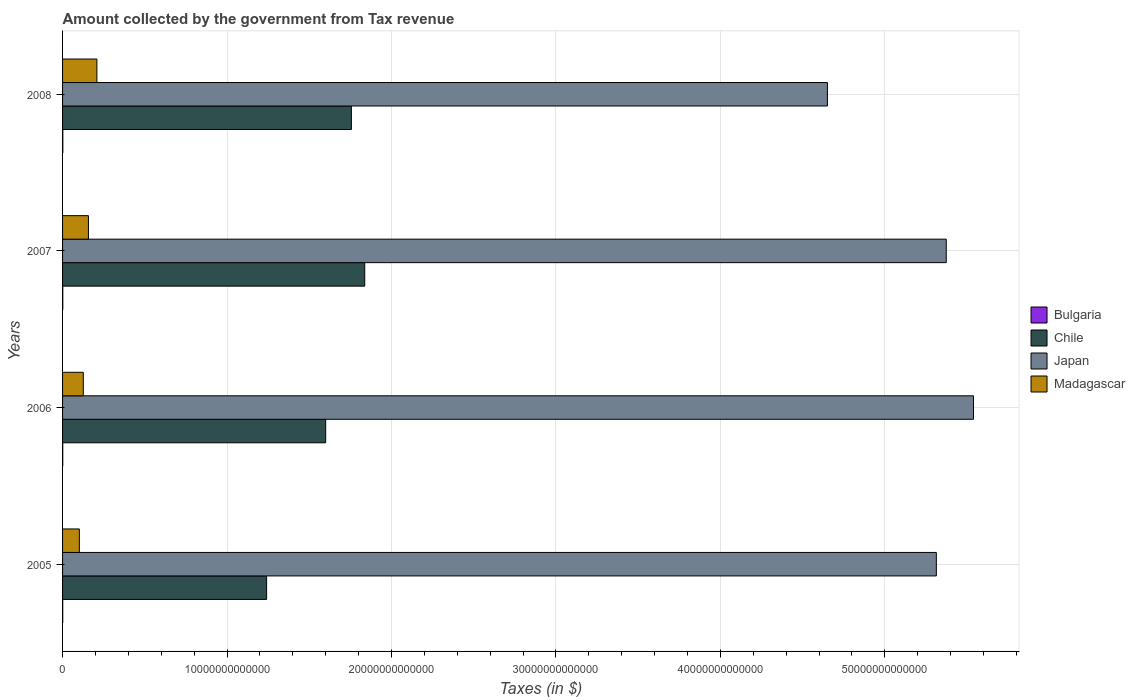How many different coloured bars are there?
Your answer should be very brief. 4. How many groups of bars are there?
Give a very brief answer. 4. How many bars are there on the 2nd tick from the top?
Your answer should be compact. 4. How many bars are there on the 3rd tick from the bottom?
Offer a terse response. 4. What is the amount collected by the government from tax revenue in Japan in 2006?
Keep it short and to the point. 5.54e+13. Across all years, what is the maximum amount collected by the government from tax revenue in Bulgaria?
Provide a short and direct response. 1.61e+1. Across all years, what is the minimum amount collected by the government from tax revenue in Bulgaria?
Ensure brevity in your answer.  9.83e+09. In which year was the amount collected by the government from tax revenue in Japan maximum?
Ensure brevity in your answer.  2006. In which year was the amount collected by the government from tax revenue in Japan minimum?
Your answer should be compact. 2008. What is the total amount collected by the government from tax revenue in Madagascar in the graph?
Keep it short and to the point. 5.94e+12. What is the difference between the amount collected by the government from tax revenue in Bulgaria in 2006 and that in 2007?
Offer a terse response. -2.27e+09. What is the difference between the amount collected by the government from tax revenue in Chile in 2006 and the amount collected by the government from tax revenue in Bulgaria in 2007?
Make the answer very short. 1.60e+13. What is the average amount collected by the government from tax revenue in Madagascar per year?
Provide a short and direct response. 1.49e+12. In the year 2006, what is the difference between the amount collected by the government from tax revenue in Bulgaria and amount collected by the government from tax revenue in Chile?
Offer a terse response. -1.60e+13. What is the ratio of the amount collected by the government from tax revenue in Bulgaria in 2007 to that in 2008?
Keep it short and to the point. 0.86. Is the amount collected by the government from tax revenue in Japan in 2006 less than that in 2007?
Make the answer very short. No. Is the difference between the amount collected by the government from tax revenue in Bulgaria in 2006 and 2008 greater than the difference between the amount collected by the government from tax revenue in Chile in 2006 and 2008?
Provide a succinct answer. Yes. What is the difference between the highest and the second highest amount collected by the government from tax revenue in Japan?
Offer a terse response. 1.66e+12. What is the difference between the highest and the lowest amount collected by the government from tax revenue in Japan?
Give a very brief answer. 8.88e+12. Is the sum of the amount collected by the government from tax revenue in Madagascar in 2005 and 2008 greater than the maximum amount collected by the government from tax revenue in Japan across all years?
Your answer should be compact. No. What does the 3rd bar from the top in 2005 represents?
Provide a short and direct response. Chile. What does the 4th bar from the bottom in 2006 represents?
Give a very brief answer. Madagascar. How many bars are there?
Provide a short and direct response. 16. Are all the bars in the graph horizontal?
Offer a very short reply. Yes. What is the difference between two consecutive major ticks on the X-axis?
Your answer should be compact. 1.00e+13. Are the values on the major ticks of X-axis written in scientific E-notation?
Offer a terse response. No. Does the graph contain any zero values?
Your response must be concise. No. Does the graph contain grids?
Offer a very short reply. Yes. How many legend labels are there?
Offer a very short reply. 4. What is the title of the graph?
Provide a succinct answer. Amount collected by the government from Tax revenue. Does "Mauritania" appear as one of the legend labels in the graph?
Offer a terse response. No. What is the label or title of the X-axis?
Make the answer very short. Taxes (in $). What is the label or title of the Y-axis?
Ensure brevity in your answer.  Years. What is the Taxes (in $) in Bulgaria in 2005?
Provide a short and direct response. 9.83e+09. What is the Taxes (in $) in Chile in 2005?
Offer a terse response. 1.24e+13. What is the Taxes (in $) in Japan in 2005?
Your answer should be very brief. 5.31e+13. What is the Taxes (in $) of Madagascar in 2005?
Your response must be concise. 1.02e+12. What is the Taxes (in $) in Bulgaria in 2006?
Your answer should be very brief. 1.17e+1. What is the Taxes (in $) in Chile in 2006?
Your answer should be compact. 1.60e+13. What is the Taxes (in $) of Japan in 2006?
Keep it short and to the point. 5.54e+13. What is the Taxes (in $) of Madagascar in 2006?
Your answer should be compact. 1.26e+12. What is the Taxes (in $) in Bulgaria in 2007?
Your answer should be very brief. 1.39e+1. What is the Taxes (in $) in Chile in 2007?
Your answer should be compact. 1.84e+13. What is the Taxes (in $) of Japan in 2007?
Your answer should be compact. 5.37e+13. What is the Taxes (in $) of Madagascar in 2007?
Your response must be concise. 1.57e+12. What is the Taxes (in $) in Bulgaria in 2008?
Provide a short and direct response. 1.61e+1. What is the Taxes (in $) in Chile in 2008?
Provide a succinct answer. 1.76e+13. What is the Taxes (in $) of Japan in 2008?
Provide a short and direct response. 4.65e+13. What is the Taxes (in $) of Madagascar in 2008?
Provide a succinct answer. 2.09e+12. Across all years, what is the maximum Taxes (in $) of Bulgaria?
Provide a succinct answer. 1.61e+1. Across all years, what is the maximum Taxes (in $) in Chile?
Provide a short and direct response. 1.84e+13. Across all years, what is the maximum Taxes (in $) in Japan?
Your answer should be compact. 5.54e+13. Across all years, what is the maximum Taxes (in $) of Madagascar?
Offer a very short reply. 2.09e+12. Across all years, what is the minimum Taxes (in $) of Bulgaria?
Make the answer very short. 9.83e+09. Across all years, what is the minimum Taxes (in $) in Chile?
Make the answer very short. 1.24e+13. Across all years, what is the minimum Taxes (in $) in Japan?
Provide a succinct answer. 4.65e+13. Across all years, what is the minimum Taxes (in $) of Madagascar?
Ensure brevity in your answer.  1.02e+12. What is the total Taxes (in $) of Bulgaria in the graph?
Provide a short and direct response. 5.15e+1. What is the total Taxes (in $) of Chile in the graph?
Give a very brief answer. 6.43e+13. What is the total Taxes (in $) of Japan in the graph?
Keep it short and to the point. 2.09e+14. What is the total Taxes (in $) in Madagascar in the graph?
Provide a short and direct response. 5.94e+12. What is the difference between the Taxes (in $) of Bulgaria in 2005 and that in 2006?
Your answer should be compact. -1.82e+09. What is the difference between the Taxes (in $) of Chile in 2005 and that in 2006?
Your answer should be compact. -3.59e+12. What is the difference between the Taxes (in $) in Japan in 2005 and that in 2006?
Ensure brevity in your answer.  -2.26e+12. What is the difference between the Taxes (in $) of Madagascar in 2005 and that in 2006?
Provide a short and direct response. -2.41e+11. What is the difference between the Taxes (in $) in Bulgaria in 2005 and that in 2007?
Your answer should be very brief. -4.09e+09. What is the difference between the Taxes (in $) in Chile in 2005 and that in 2007?
Ensure brevity in your answer.  -5.97e+12. What is the difference between the Taxes (in $) in Japan in 2005 and that in 2007?
Provide a succinct answer. -6.02e+11. What is the difference between the Taxes (in $) in Madagascar in 2005 and that in 2007?
Your response must be concise. -5.53e+11. What is the difference between the Taxes (in $) in Bulgaria in 2005 and that in 2008?
Your answer should be very brief. -6.30e+09. What is the difference between the Taxes (in $) of Chile in 2005 and that in 2008?
Keep it short and to the point. -5.15e+12. What is the difference between the Taxes (in $) in Japan in 2005 and that in 2008?
Provide a short and direct response. 6.62e+12. What is the difference between the Taxes (in $) of Madagascar in 2005 and that in 2008?
Ensure brevity in your answer.  -1.07e+12. What is the difference between the Taxes (in $) in Bulgaria in 2006 and that in 2007?
Keep it short and to the point. -2.27e+09. What is the difference between the Taxes (in $) of Chile in 2006 and that in 2007?
Ensure brevity in your answer.  -2.37e+12. What is the difference between the Taxes (in $) in Japan in 2006 and that in 2007?
Your answer should be very brief. 1.66e+12. What is the difference between the Taxes (in $) of Madagascar in 2006 and that in 2007?
Keep it short and to the point. -3.12e+11. What is the difference between the Taxes (in $) of Bulgaria in 2006 and that in 2008?
Your answer should be compact. -4.47e+09. What is the difference between the Taxes (in $) of Chile in 2006 and that in 2008?
Provide a succinct answer. -1.56e+12. What is the difference between the Taxes (in $) in Japan in 2006 and that in 2008?
Your response must be concise. 8.88e+12. What is the difference between the Taxes (in $) of Madagascar in 2006 and that in 2008?
Keep it short and to the point. -8.26e+11. What is the difference between the Taxes (in $) of Bulgaria in 2007 and that in 2008?
Your response must be concise. -2.20e+09. What is the difference between the Taxes (in $) of Chile in 2007 and that in 2008?
Provide a short and direct response. 8.12e+11. What is the difference between the Taxes (in $) in Japan in 2007 and that in 2008?
Your response must be concise. 7.23e+12. What is the difference between the Taxes (in $) of Madagascar in 2007 and that in 2008?
Your answer should be compact. -5.14e+11. What is the difference between the Taxes (in $) of Bulgaria in 2005 and the Taxes (in $) of Chile in 2006?
Your answer should be compact. -1.60e+13. What is the difference between the Taxes (in $) of Bulgaria in 2005 and the Taxes (in $) of Japan in 2006?
Offer a terse response. -5.54e+13. What is the difference between the Taxes (in $) in Bulgaria in 2005 and the Taxes (in $) in Madagascar in 2006?
Offer a terse response. -1.25e+12. What is the difference between the Taxes (in $) in Chile in 2005 and the Taxes (in $) in Japan in 2006?
Offer a terse response. -4.30e+13. What is the difference between the Taxes (in $) in Chile in 2005 and the Taxes (in $) in Madagascar in 2006?
Offer a very short reply. 1.11e+13. What is the difference between the Taxes (in $) of Japan in 2005 and the Taxes (in $) of Madagascar in 2006?
Your response must be concise. 5.19e+13. What is the difference between the Taxes (in $) of Bulgaria in 2005 and the Taxes (in $) of Chile in 2007?
Your answer should be very brief. -1.84e+13. What is the difference between the Taxes (in $) of Bulgaria in 2005 and the Taxes (in $) of Japan in 2007?
Make the answer very short. -5.37e+13. What is the difference between the Taxes (in $) in Bulgaria in 2005 and the Taxes (in $) in Madagascar in 2007?
Keep it short and to the point. -1.56e+12. What is the difference between the Taxes (in $) in Chile in 2005 and the Taxes (in $) in Japan in 2007?
Provide a short and direct response. -4.13e+13. What is the difference between the Taxes (in $) in Chile in 2005 and the Taxes (in $) in Madagascar in 2007?
Provide a short and direct response. 1.08e+13. What is the difference between the Taxes (in $) of Japan in 2005 and the Taxes (in $) of Madagascar in 2007?
Give a very brief answer. 5.16e+13. What is the difference between the Taxes (in $) of Bulgaria in 2005 and the Taxes (in $) of Chile in 2008?
Give a very brief answer. -1.76e+13. What is the difference between the Taxes (in $) in Bulgaria in 2005 and the Taxes (in $) in Japan in 2008?
Your answer should be compact. -4.65e+13. What is the difference between the Taxes (in $) in Bulgaria in 2005 and the Taxes (in $) in Madagascar in 2008?
Provide a succinct answer. -2.08e+12. What is the difference between the Taxes (in $) in Chile in 2005 and the Taxes (in $) in Japan in 2008?
Make the answer very short. -3.41e+13. What is the difference between the Taxes (in $) in Chile in 2005 and the Taxes (in $) in Madagascar in 2008?
Keep it short and to the point. 1.03e+13. What is the difference between the Taxes (in $) of Japan in 2005 and the Taxes (in $) of Madagascar in 2008?
Your answer should be very brief. 5.10e+13. What is the difference between the Taxes (in $) in Bulgaria in 2006 and the Taxes (in $) in Chile in 2007?
Your answer should be very brief. -1.84e+13. What is the difference between the Taxes (in $) in Bulgaria in 2006 and the Taxes (in $) in Japan in 2007?
Provide a short and direct response. -5.37e+13. What is the difference between the Taxes (in $) of Bulgaria in 2006 and the Taxes (in $) of Madagascar in 2007?
Provide a short and direct response. -1.56e+12. What is the difference between the Taxes (in $) of Chile in 2006 and the Taxes (in $) of Japan in 2007?
Provide a succinct answer. -3.77e+13. What is the difference between the Taxes (in $) in Chile in 2006 and the Taxes (in $) in Madagascar in 2007?
Keep it short and to the point. 1.44e+13. What is the difference between the Taxes (in $) in Japan in 2006 and the Taxes (in $) in Madagascar in 2007?
Make the answer very short. 5.38e+13. What is the difference between the Taxes (in $) in Bulgaria in 2006 and the Taxes (in $) in Chile in 2008?
Offer a terse response. -1.76e+13. What is the difference between the Taxes (in $) of Bulgaria in 2006 and the Taxes (in $) of Japan in 2008?
Offer a terse response. -4.65e+13. What is the difference between the Taxes (in $) in Bulgaria in 2006 and the Taxes (in $) in Madagascar in 2008?
Give a very brief answer. -2.08e+12. What is the difference between the Taxes (in $) in Chile in 2006 and the Taxes (in $) in Japan in 2008?
Your response must be concise. -3.05e+13. What is the difference between the Taxes (in $) of Chile in 2006 and the Taxes (in $) of Madagascar in 2008?
Keep it short and to the point. 1.39e+13. What is the difference between the Taxes (in $) in Japan in 2006 and the Taxes (in $) in Madagascar in 2008?
Your answer should be very brief. 5.33e+13. What is the difference between the Taxes (in $) of Bulgaria in 2007 and the Taxes (in $) of Chile in 2008?
Provide a succinct answer. -1.75e+13. What is the difference between the Taxes (in $) in Bulgaria in 2007 and the Taxes (in $) in Japan in 2008?
Offer a very short reply. -4.65e+13. What is the difference between the Taxes (in $) of Bulgaria in 2007 and the Taxes (in $) of Madagascar in 2008?
Your response must be concise. -2.07e+12. What is the difference between the Taxes (in $) of Chile in 2007 and the Taxes (in $) of Japan in 2008?
Your answer should be compact. -2.81e+13. What is the difference between the Taxes (in $) in Chile in 2007 and the Taxes (in $) in Madagascar in 2008?
Your answer should be compact. 1.63e+13. What is the difference between the Taxes (in $) in Japan in 2007 and the Taxes (in $) in Madagascar in 2008?
Give a very brief answer. 5.16e+13. What is the average Taxes (in $) in Bulgaria per year?
Your answer should be compact. 1.29e+1. What is the average Taxes (in $) in Chile per year?
Make the answer very short. 1.61e+13. What is the average Taxes (in $) in Japan per year?
Make the answer very short. 5.22e+13. What is the average Taxes (in $) of Madagascar per year?
Your answer should be compact. 1.49e+12. In the year 2005, what is the difference between the Taxes (in $) of Bulgaria and Taxes (in $) of Chile?
Your response must be concise. -1.24e+13. In the year 2005, what is the difference between the Taxes (in $) of Bulgaria and Taxes (in $) of Japan?
Keep it short and to the point. -5.31e+13. In the year 2005, what is the difference between the Taxes (in $) in Bulgaria and Taxes (in $) in Madagascar?
Give a very brief answer. -1.01e+12. In the year 2005, what is the difference between the Taxes (in $) in Chile and Taxes (in $) in Japan?
Your answer should be very brief. -4.07e+13. In the year 2005, what is the difference between the Taxes (in $) in Chile and Taxes (in $) in Madagascar?
Give a very brief answer. 1.14e+13. In the year 2005, what is the difference between the Taxes (in $) of Japan and Taxes (in $) of Madagascar?
Make the answer very short. 5.21e+13. In the year 2006, what is the difference between the Taxes (in $) in Bulgaria and Taxes (in $) in Chile?
Keep it short and to the point. -1.60e+13. In the year 2006, what is the difference between the Taxes (in $) of Bulgaria and Taxes (in $) of Japan?
Your response must be concise. -5.54e+13. In the year 2006, what is the difference between the Taxes (in $) of Bulgaria and Taxes (in $) of Madagascar?
Ensure brevity in your answer.  -1.25e+12. In the year 2006, what is the difference between the Taxes (in $) in Chile and Taxes (in $) in Japan?
Provide a succinct answer. -3.94e+13. In the year 2006, what is the difference between the Taxes (in $) in Chile and Taxes (in $) in Madagascar?
Provide a succinct answer. 1.47e+13. In the year 2006, what is the difference between the Taxes (in $) of Japan and Taxes (in $) of Madagascar?
Provide a short and direct response. 5.41e+13. In the year 2007, what is the difference between the Taxes (in $) of Bulgaria and Taxes (in $) of Chile?
Make the answer very short. -1.84e+13. In the year 2007, what is the difference between the Taxes (in $) in Bulgaria and Taxes (in $) in Japan?
Make the answer very short. -5.37e+13. In the year 2007, what is the difference between the Taxes (in $) of Bulgaria and Taxes (in $) of Madagascar?
Make the answer very short. -1.56e+12. In the year 2007, what is the difference between the Taxes (in $) of Chile and Taxes (in $) of Japan?
Give a very brief answer. -3.54e+13. In the year 2007, what is the difference between the Taxes (in $) in Chile and Taxes (in $) in Madagascar?
Provide a short and direct response. 1.68e+13. In the year 2007, what is the difference between the Taxes (in $) of Japan and Taxes (in $) of Madagascar?
Provide a short and direct response. 5.22e+13. In the year 2008, what is the difference between the Taxes (in $) in Bulgaria and Taxes (in $) in Chile?
Your response must be concise. -1.75e+13. In the year 2008, what is the difference between the Taxes (in $) in Bulgaria and Taxes (in $) in Japan?
Your response must be concise. -4.65e+13. In the year 2008, what is the difference between the Taxes (in $) of Bulgaria and Taxes (in $) of Madagascar?
Your response must be concise. -2.07e+12. In the year 2008, what is the difference between the Taxes (in $) of Chile and Taxes (in $) of Japan?
Your response must be concise. -2.89e+13. In the year 2008, what is the difference between the Taxes (in $) in Chile and Taxes (in $) in Madagascar?
Offer a very short reply. 1.55e+13. In the year 2008, what is the difference between the Taxes (in $) of Japan and Taxes (in $) of Madagascar?
Keep it short and to the point. 4.44e+13. What is the ratio of the Taxes (in $) of Bulgaria in 2005 to that in 2006?
Give a very brief answer. 0.84. What is the ratio of the Taxes (in $) of Chile in 2005 to that in 2006?
Ensure brevity in your answer.  0.78. What is the ratio of the Taxes (in $) of Japan in 2005 to that in 2006?
Offer a very short reply. 0.96. What is the ratio of the Taxes (in $) in Madagascar in 2005 to that in 2006?
Offer a terse response. 0.81. What is the ratio of the Taxes (in $) of Bulgaria in 2005 to that in 2007?
Offer a terse response. 0.71. What is the ratio of the Taxes (in $) in Chile in 2005 to that in 2007?
Provide a short and direct response. 0.68. What is the ratio of the Taxes (in $) in Japan in 2005 to that in 2007?
Your answer should be compact. 0.99. What is the ratio of the Taxes (in $) of Madagascar in 2005 to that in 2007?
Provide a succinct answer. 0.65. What is the ratio of the Taxes (in $) in Bulgaria in 2005 to that in 2008?
Your answer should be compact. 0.61. What is the ratio of the Taxes (in $) in Chile in 2005 to that in 2008?
Make the answer very short. 0.71. What is the ratio of the Taxes (in $) of Japan in 2005 to that in 2008?
Your answer should be compact. 1.14. What is the ratio of the Taxes (in $) in Madagascar in 2005 to that in 2008?
Offer a terse response. 0.49. What is the ratio of the Taxes (in $) of Bulgaria in 2006 to that in 2007?
Provide a succinct answer. 0.84. What is the ratio of the Taxes (in $) in Chile in 2006 to that in 2007?
Provide a short and direct response. 0.87. What is the ratio of the Taxes (in $) in Japan in 2006 to that in 2007?
Provide a succinct answer. 1.03. What is the ratio of the Taxes (in $) in Madagascar in 2006 to that in 2007?
Give a very brief answer. 0.8. What is the ratio of the Taxes (in $) of Bulgaria in 2006 to that in 2008?
Your answer should be very brief. 0.72. What is the ratio of the Taxes (in $) in Chile in 2006 to that in 2008?
Your answer should be very brief. 0.91. What is the ratio of the Taxes (in $) of Japan in 2006 to that in 2008?
Ensure brevity in your answer.  1.19. What is the ratio of the Taxes (in $) in Madagascar in 2006 to that in 2008?
Provide a short and direct response. 0.6. What is the ratio of the Taxes (in $) of Bulgaria in 2007 to that in 2008?
Ensure brevity in your answer.  0.86. What is the ratio of the Taxes (in $) of Chile in 2007 to that in 2008?
Offer a very short reply. 1.05. What is the ratio of the Taxes (in $) of Japan in 2007 to that in 2008?
Your response must be concise. 1.16. What is the ratio of the Taxes (in $) in Madagascar in 2007 to that in 2008?
Offer a terse response. 0.75. What is the difference between the highest and the second highest Taxes (in $) in Bulgaria?
Give a very brief answer. 2.20e+09. What is the difference between the highest and the second highest Taxes (in $) of Chile?
Your answer should be very brief. 8.12e+11. What is the difference between the highest and the second highest Taxes (in $) in Japan?
Give a very brief answer. 1.66e+12. What is the difference between the highest and the second highest Taxes (in $) in Madagascar?
Give a very brief answer. 5.14e+11. What is the difference between the highest and the lowest Taxes (in $) in Bulgaria?
Provide a succinct answer. 6.30e+09. What is the difference between the highest and the lowest Taxes (in $) in Chile?
Offer a very short reply. 5.97e+12. What is the difference between the highest and the lowest Taxes (in $) in Japan?
Your response must be concise. 8.88e+12. What is the difference between the highest and the lowest Taxes (in $) in Madagascar?
Give a very brief answer. 1.07e+12. 